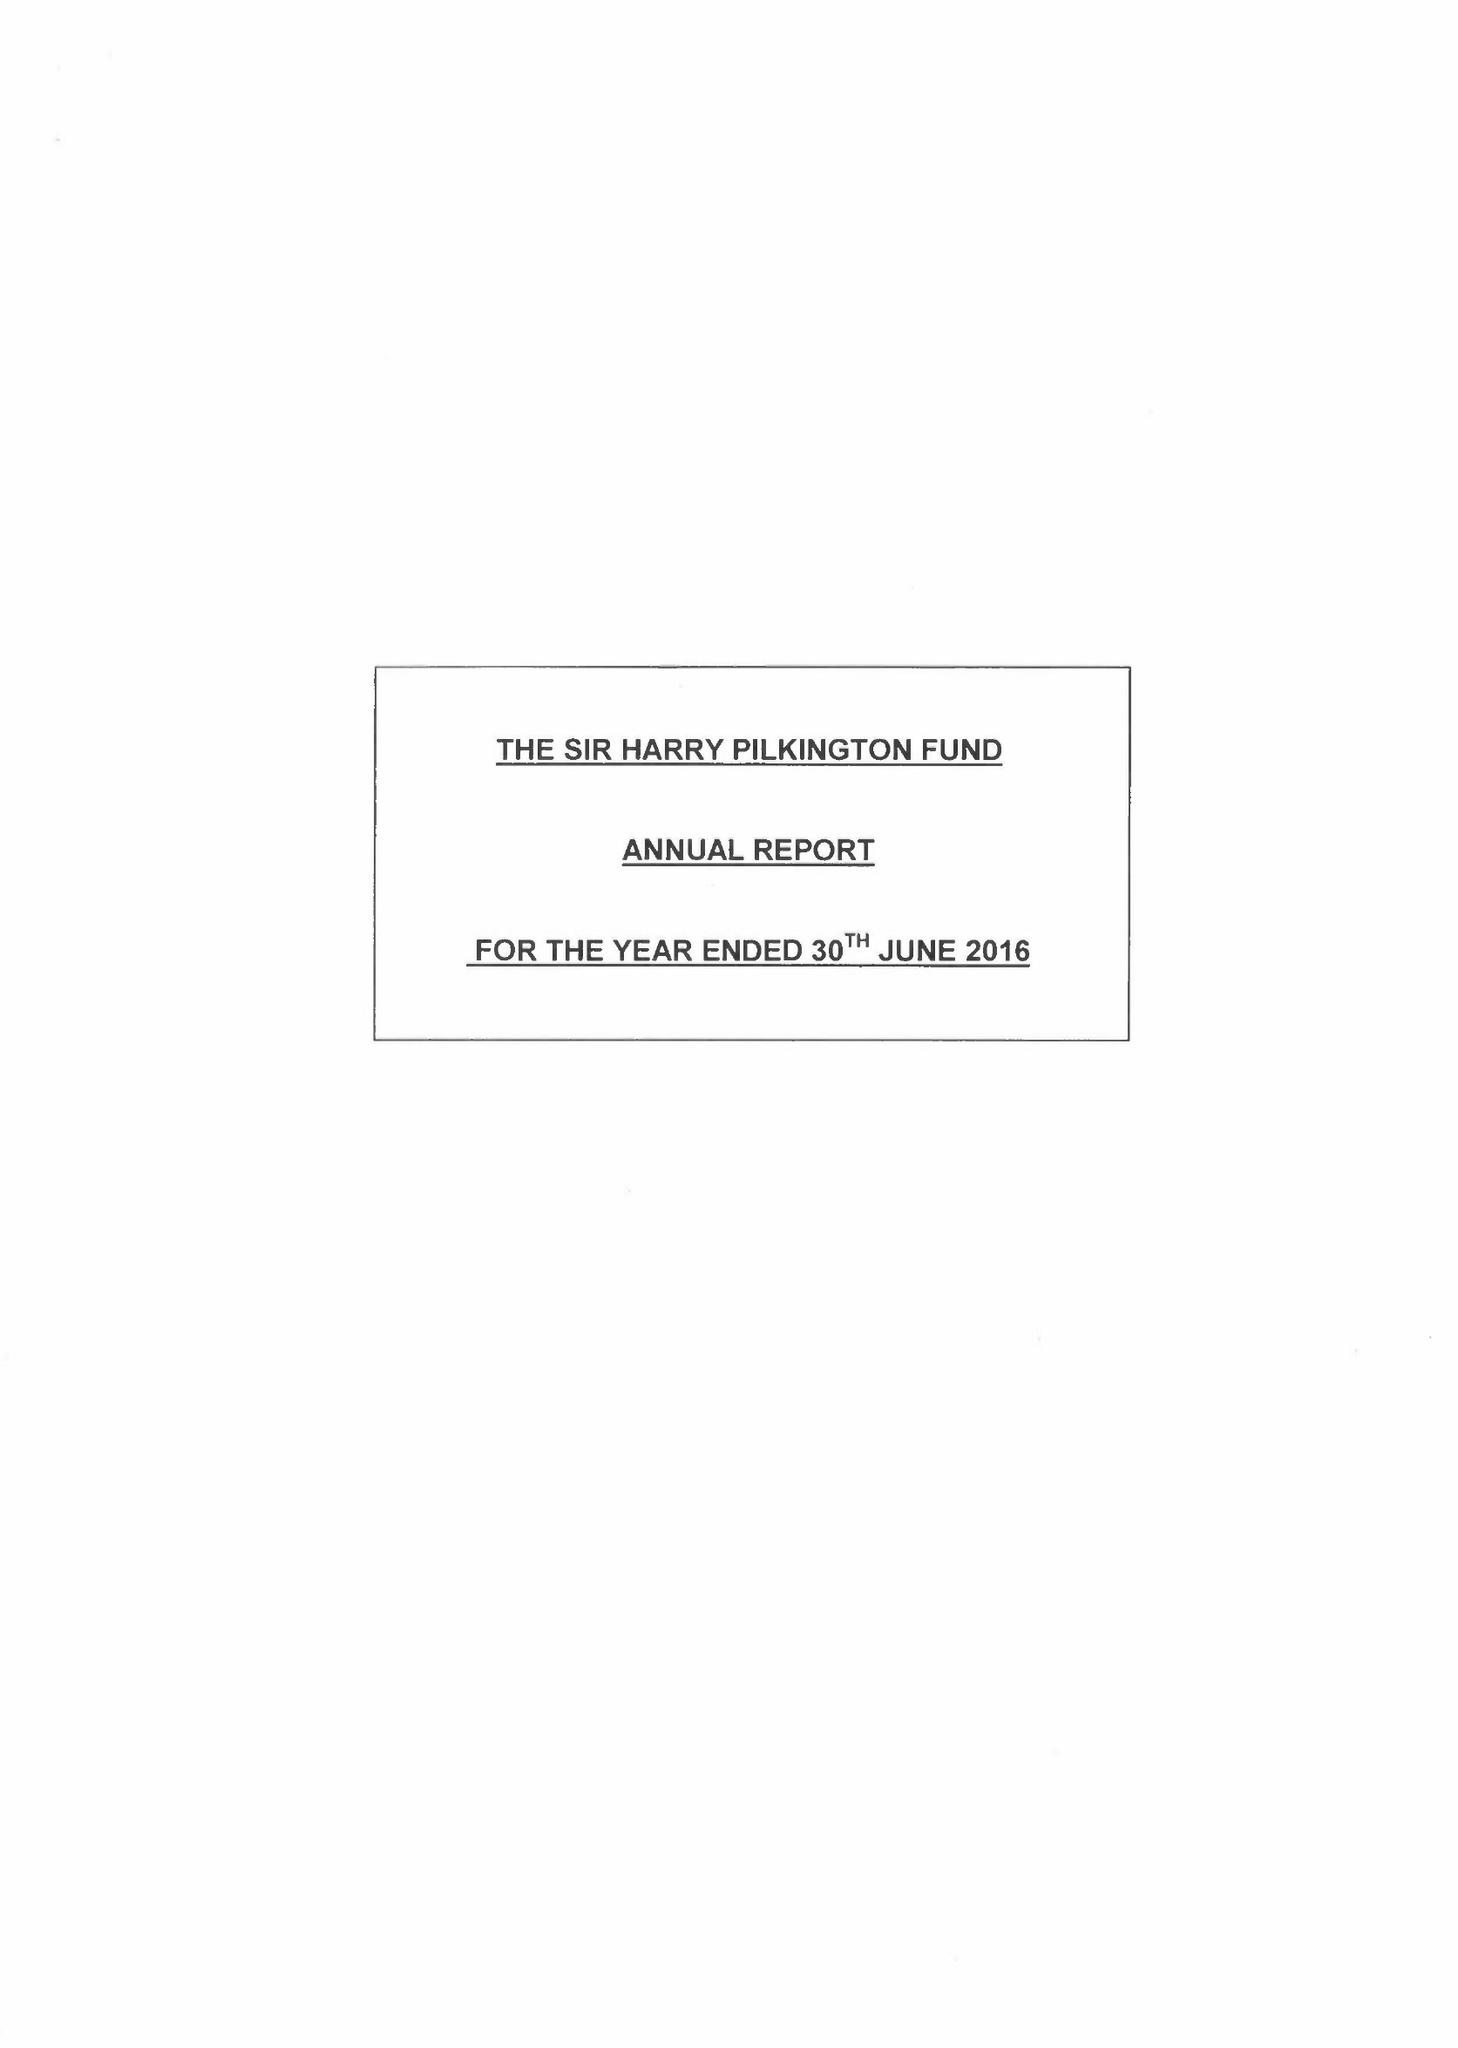What is the value for the address__street_line?
Answer the question using a single word or phrase. 151 DALE STREET 